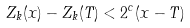Convert formula to latex. <formula><loc_0><loc_0><loc_500><loc_500>Z _ { k } ( x ) - Z _ { k } ( T ) < 2 ^ { c } ( x - T )</formula> 